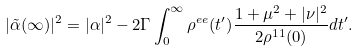<formula> <loc_0><loc_0><loc_500><loc_500>| \tilde { \alpha } ( \infty ) | ^ { 2 } = | \alpha | ^ { 2 } - 2 \Gamma \int _ { 0 } ^ { \infty } \rho ^ { e e } ( t ^ { \prime } ) \frac { 1 + \mu ^ { 2 } + | \nu | ^ { 2 } } { 2 \rho ^ { 1 1 } ( 0 ) } d t ^ { \prime } .</formula> 